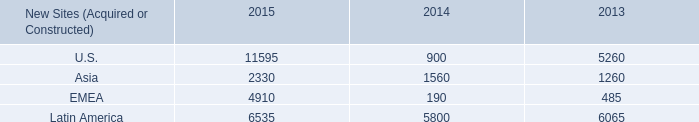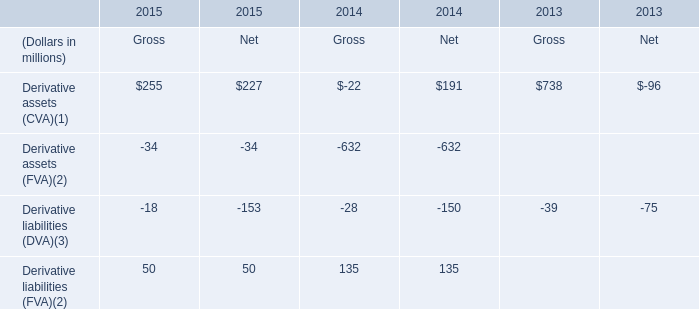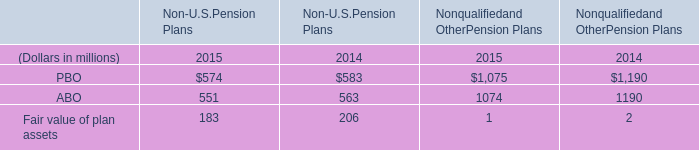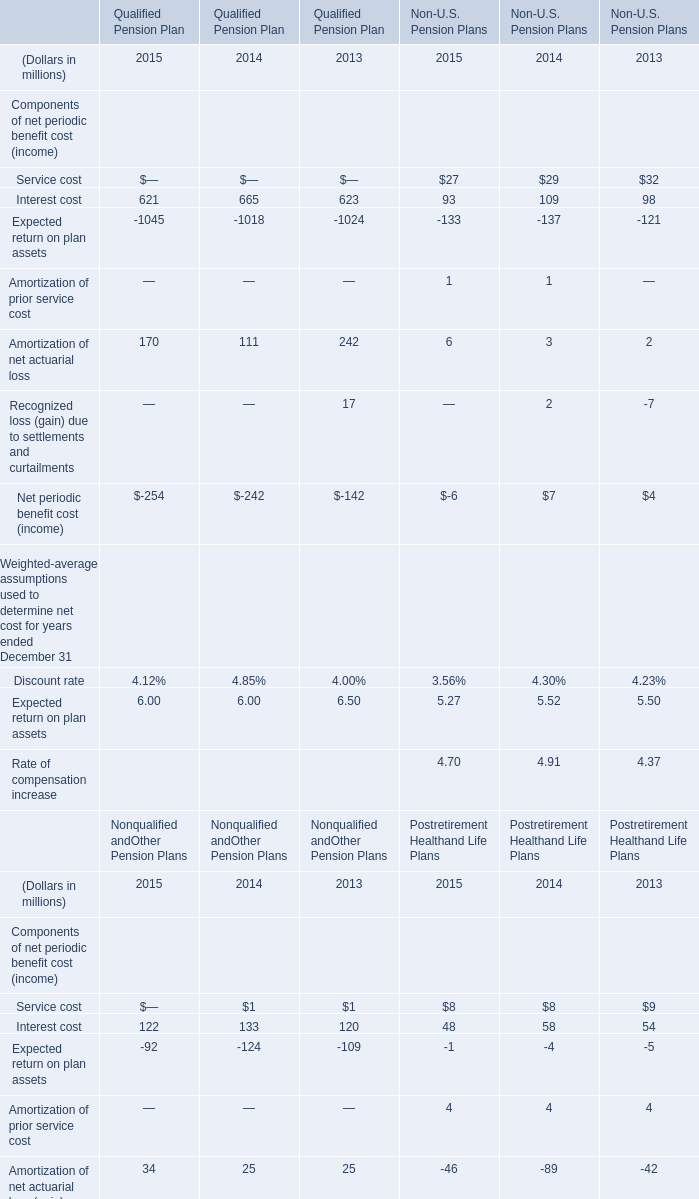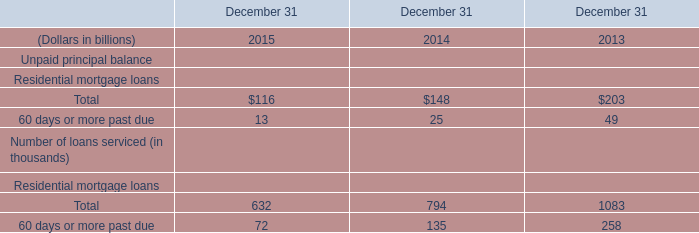What's the sum of Fair value of plan assets in 2015? (in million) 
Computations: (183 + 1)
Answer: 184.0. 